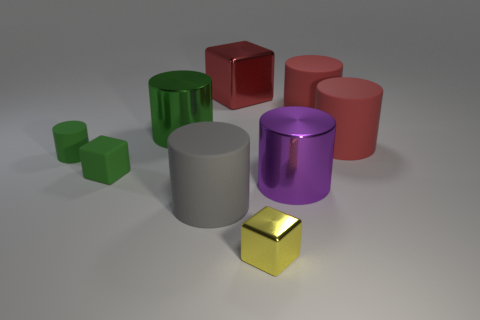How many green things are on the right side of the tiny green matte cylinder and behind the small rubber cube?
Make the answer very short. 1. What is the material of the tiny green cube?
Your answer should be compact. Rubber. Are there the same number of shiny cylinders behind the large block and balls?
Keep it short and to the point. Yes. How many green objects have the same shape as the yellow metal thing?
Give a very brief answer. 1. Is the shape of the yellow metal object the same as the gray rubber thing?
Keep it short and to the point. No. What number of things are big rubber cylinders behind the tiny green cylinder or yellow objects?
Offer a terse response. 3. There is a big red object to the left of the cube that is in front of the large metal cylinder to the right of the tiny metallic block; what shape is it?
Offer a terse response. Cube. There is a large red object that is the same material as the small yellow block; what shape is it?
Offer a terse response. Cube. What is the size of the gray cylinder?
Provide a succinct answer. Large. Do the yellow shiny cube and the green matte cube have the same size?
Give a very brief answer. Yes. 